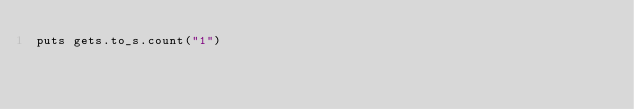Convert code to text. <code><loc_0><loc_0><loc_500><loc_500><_Crystal_>puts gets.to_s.count("1")</code> 